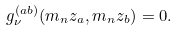<formula> <loc_0><loc_0><loc_500><loc_500>g _ { \nu } ^ { ( a b ) } ( m _ { n } z _ { a } , m _ { n } z _ { b } ) = 0 .</formula> 